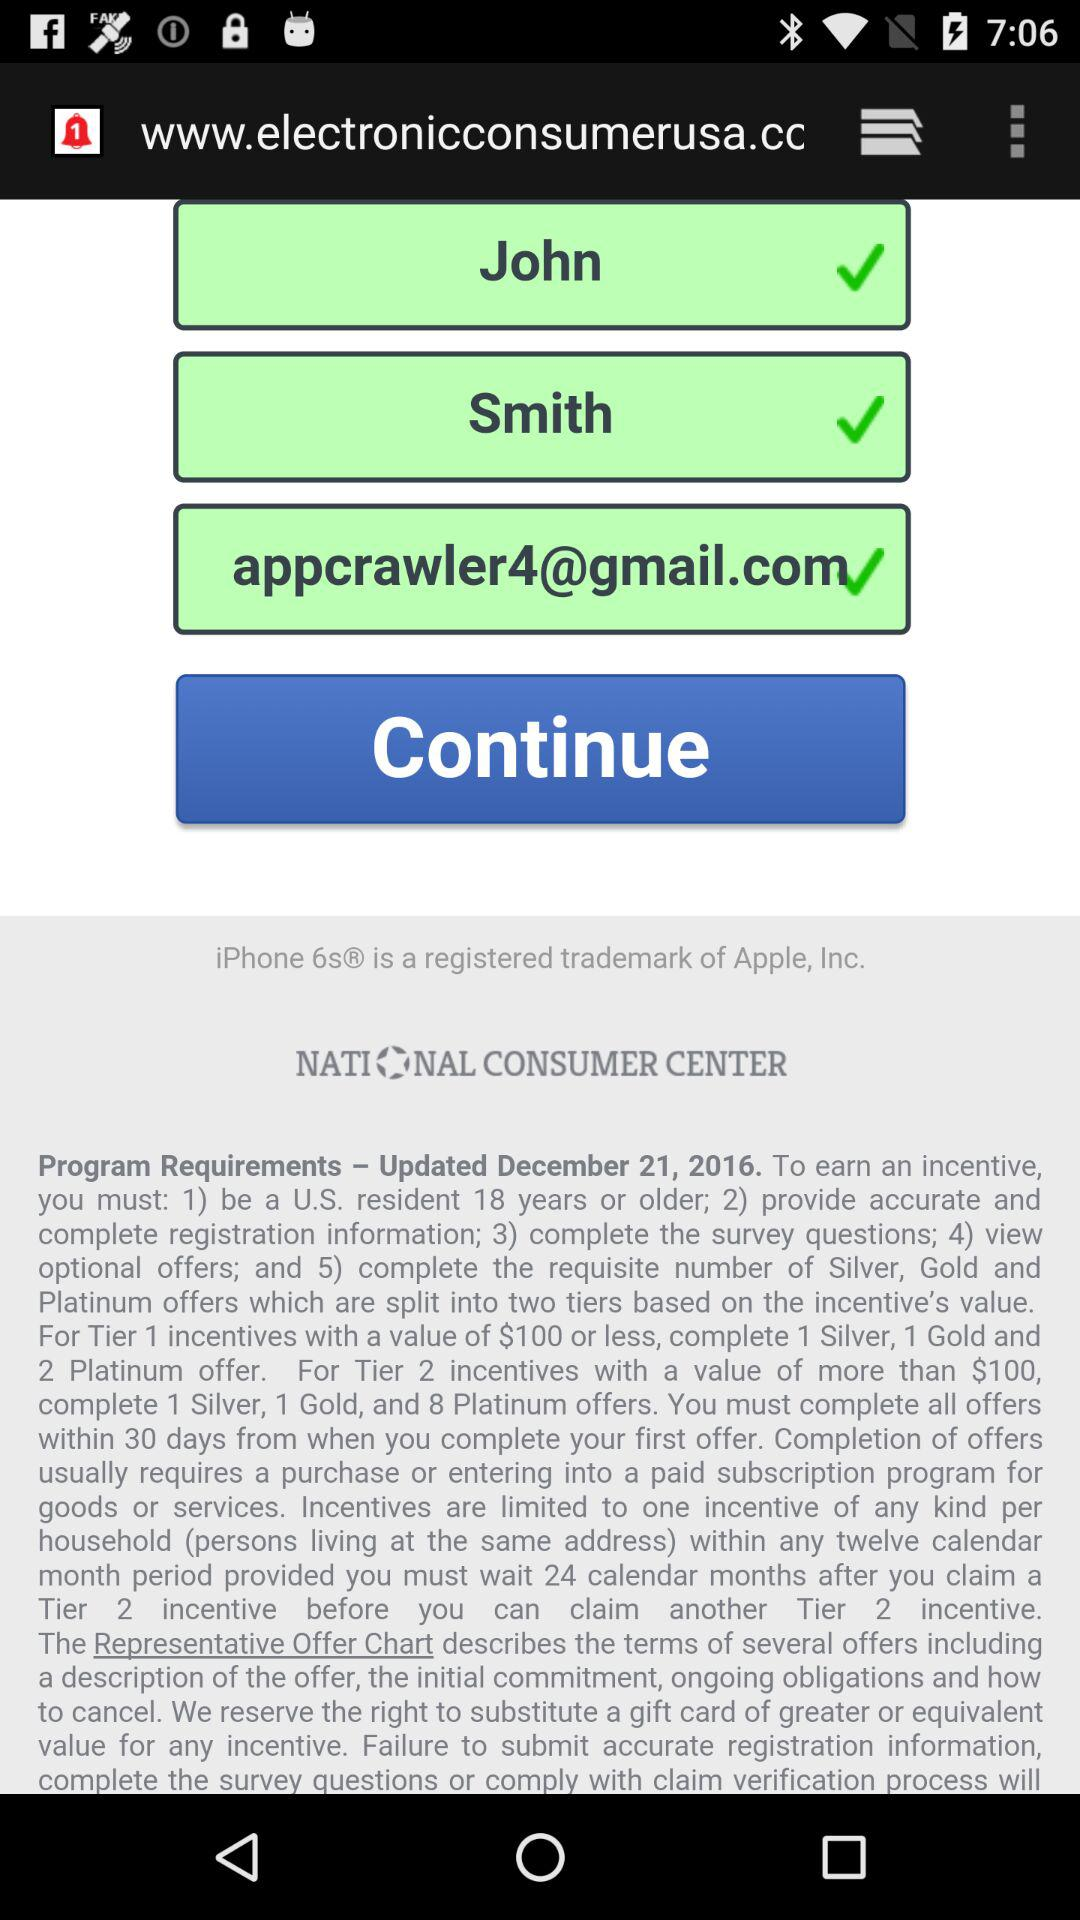How many calendar months must you wait after claiming a Tier 2 incentive before you can claim another Tier 2 incentive?
Answer the question using a single word or phrase. 24 